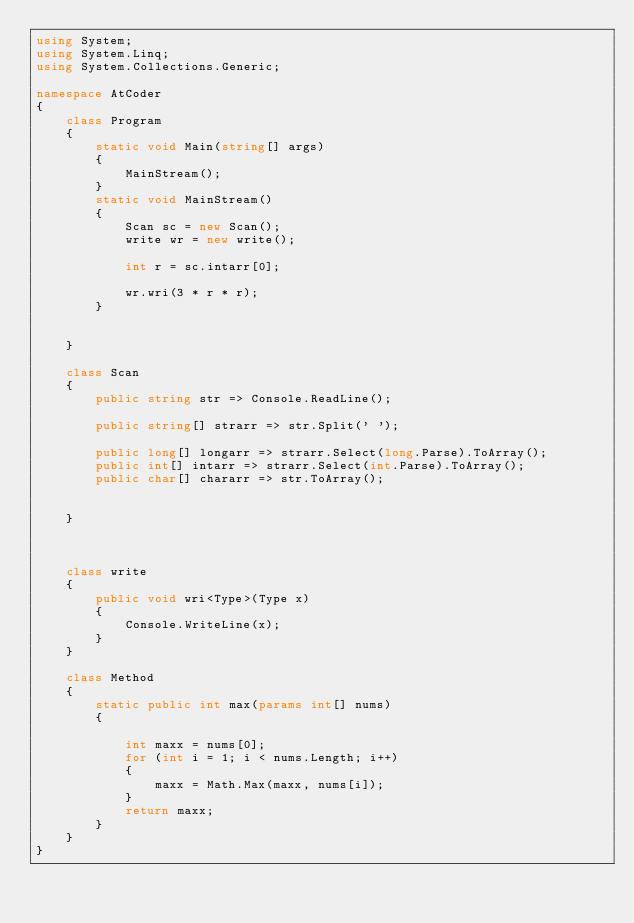Convert code to text. <code><loc_0><loc_0><loc_500><loc_500><_C#_>using System;
using System.Linq;
using System.Collections.Generic;

namespace AtCoder
{
    class Program
    {
        static void Main(string[] args)
        {
            MainStream();
        }
        static void MainStream()
        {
            Scan sc = new Scan();
            write wr = new write();

            int r = sc.intarr[0];

            wr.wri(3 * r * r);
        }


    }

    class Scan
    {
        public string str => Console.ReadLine();

        public string[] strarr => str.Split(' ');

        public long[] longarr => strarr.Select(long.Parse).ToArray();
        public int[] intarr => strarr.Select(int.Parse).ToArray();
        public char[] chararr => str.ToArray();


    }



    class write
    {
        public void wri<Type>(Type x)
        {
            Console.WriteLine(x);
        }
    }

    class Method
    {
        static public int max(params int[] nums)
        {

            int maxx = nums[0];
            for (int i = 1; i < nums.Length; i++)
            {
                maxx = Math.Max(maxx, nums[i]);
            }
            return maxx;
        }
    }
}
</code> 